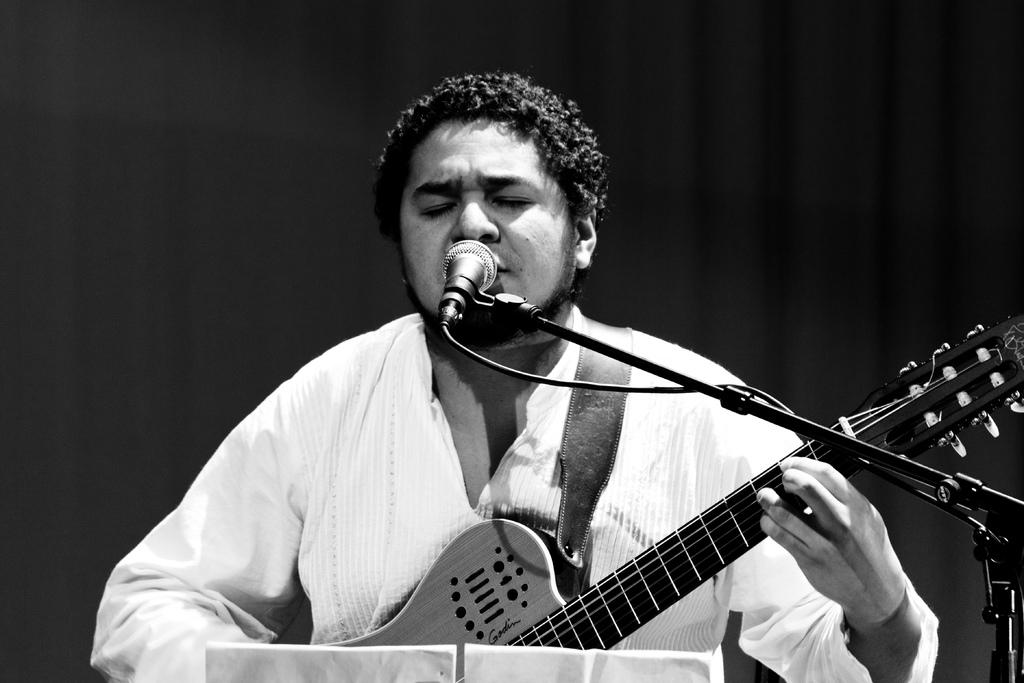What is the person in the image doing? The person is sitting and singing in the image. What instrument is the person holding? The person is holding a guitar in his hands. What object is in front of the person? There is a microphone in front of the person. What type of plane can be seen flying in the background of the image? There is no plane visible in the image; it only features a person sitting, singing, and holding a guitar with a microphone in front of him. 